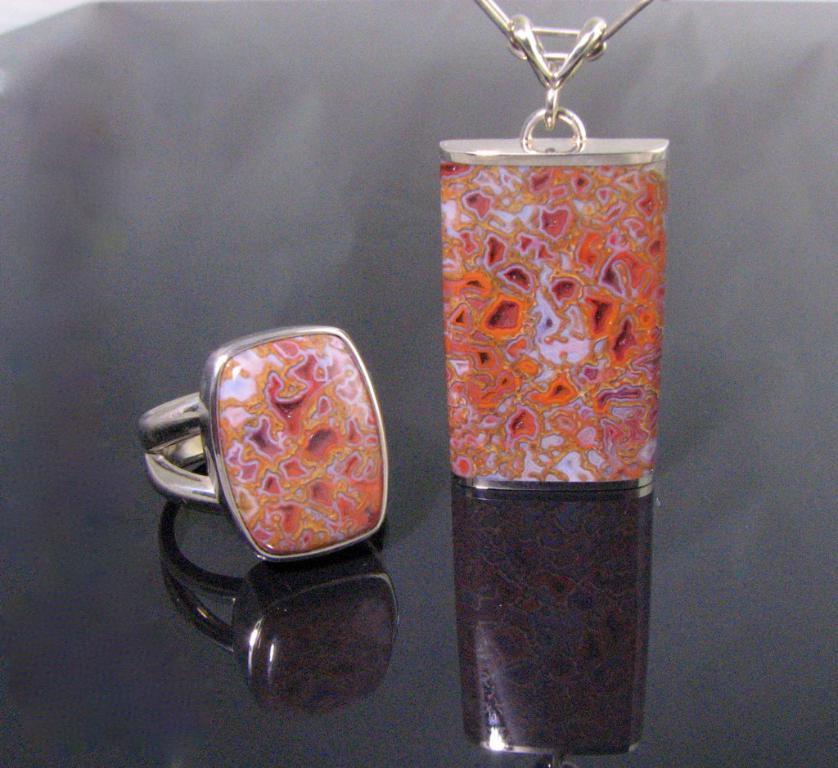Could you give a brief overview of what you see in this image? In this picture we can see a ring and a locket and these two are placed on a platform. 